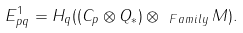<formula> <loc_0><loc_0><loc_500><loc_500>E ^ { 1 } _ { p q } = H _ { q } ( ( C _ { p } \otimes Q _ { * } ) \otimes _ { \ F a m i l y } M ) .</formula> 